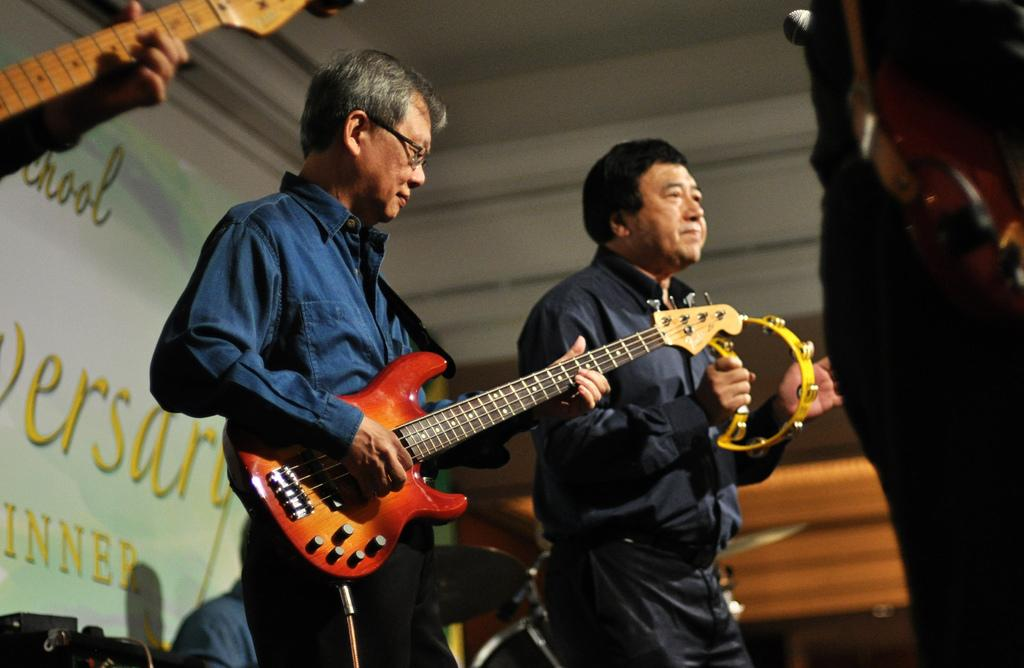What are the people in the middle of the image doing? The people in the middle of the image are holding music instruments. What can be seen on the left side of the image? There is a white color poster on the left side of the image, and the roof and wall are also white in color. What type of fuel is being used by the people in the image? There is no mention of fuel or any fuel-related activity in the image. 